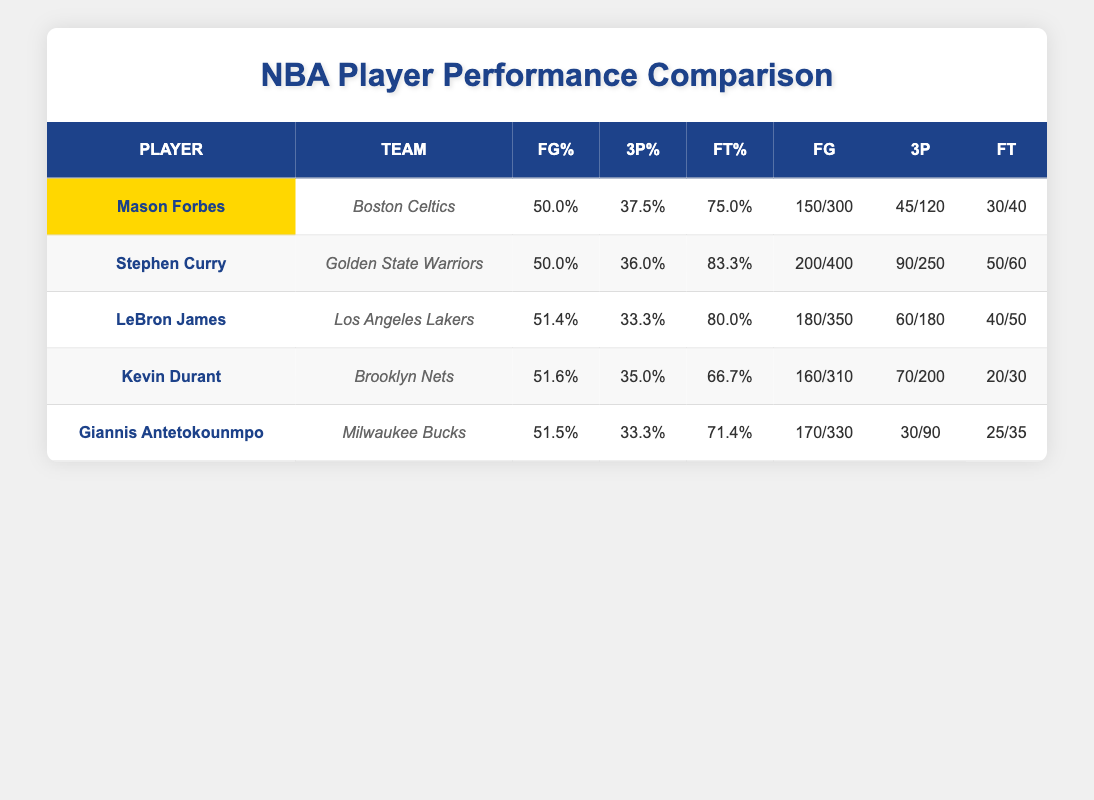What is Mason Forbes' three-point shooting percentage? Mason Forbes' three-point field goal percentage is directly listed in the table under the 3P% column, which shows 37.5%.
Answer: 37.5% How many free throws did Stephen Curry make? The number of free throws made by Stephen Curry is shown in the FT column of the table, which states he made 50 free throws.
Answer: 50 Who has the highest field goal percentage among the players listed? By comparing the FG% values in the table, LeBron James has the highest field goal percentage at 51.4%.
Answer: LeBron James What is the average free throw percentage of all players? To calculate the average free throw percentage, add up the free throw percentages (75.0 + 83.3 + 80.0 + 66.7 + 71.4) = 376.4 and divide by 5, resulting in an average of 75.28%.
Answer: 75.28% Is Mason Forbes' free throw percentage higher than Kevin Durant's? Mason Forbes' free throw percentage (75.0%) is compared to Kevin Durant's (66.7%). Since 75.0% is greater than 66.7%, the statement is true.
Answer: Yes Which player has the highest total field goals made? By reviewing the FG column, Stephen Curry has the highest total field goals made with 200 field goals.
Answer: Stephen Curry What is the difference in free throws made between Mason Forbes and Giannis Antetokounmpo? Mason Forbes made 30 free throws while Giannis Antetokounmpo made 25. The difference is calculated as 30 - 25 = 5.
Answer: 5 Who had a higher three-point field goal percentage, Mason Forbes or LeBron James? Mason Forbes has a three-point percentage of 37.5%, while LeBron James has 33.3%. Comparing these values shows that Mason Forbes has a higher percentage.
Answer: Yes What percentage of Mason Forbes' total field goals were three-pointers? Mason Forbes made 45 three-pointers out of 150 total field goals. The calculation is (45/150)*100 = 30%.
Answer: 30% 